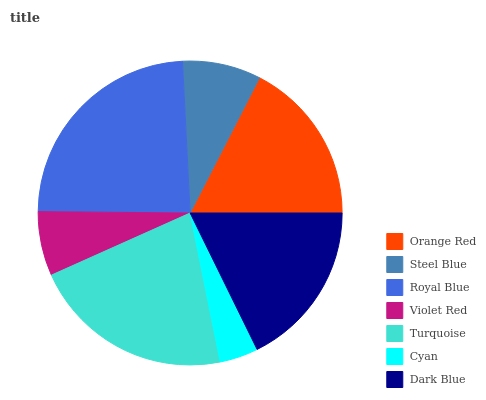Is Cyan the minimum?
Answer yes or no. Yes. Is Royal Blue the maximum?
Answer yes or no. Yes. Is Steel Blue the minimum?
Answer yes or no. No. Is Steel Blue the maximum?
Answer yes or no. No. Is Orange Red greater than Steel Blue?
Answer yes or no. Yes. Is Steel Blue less than Orange Red?
Answer yes or no. Yes. Is Steel Blue greater than Orange Red?
Answer yes or no. No. Is Orange Red less than Steel Blue?
Answer yes or no. No. Is Orange Red the high median?
Answer yes or no. Yes. Is Orange Red the low median?
Answer yes or no. Yes. Is Dark Blue the high median?
Answer yes or no. No. Is Royal Blue the low median?
Answer yes or no. No. 